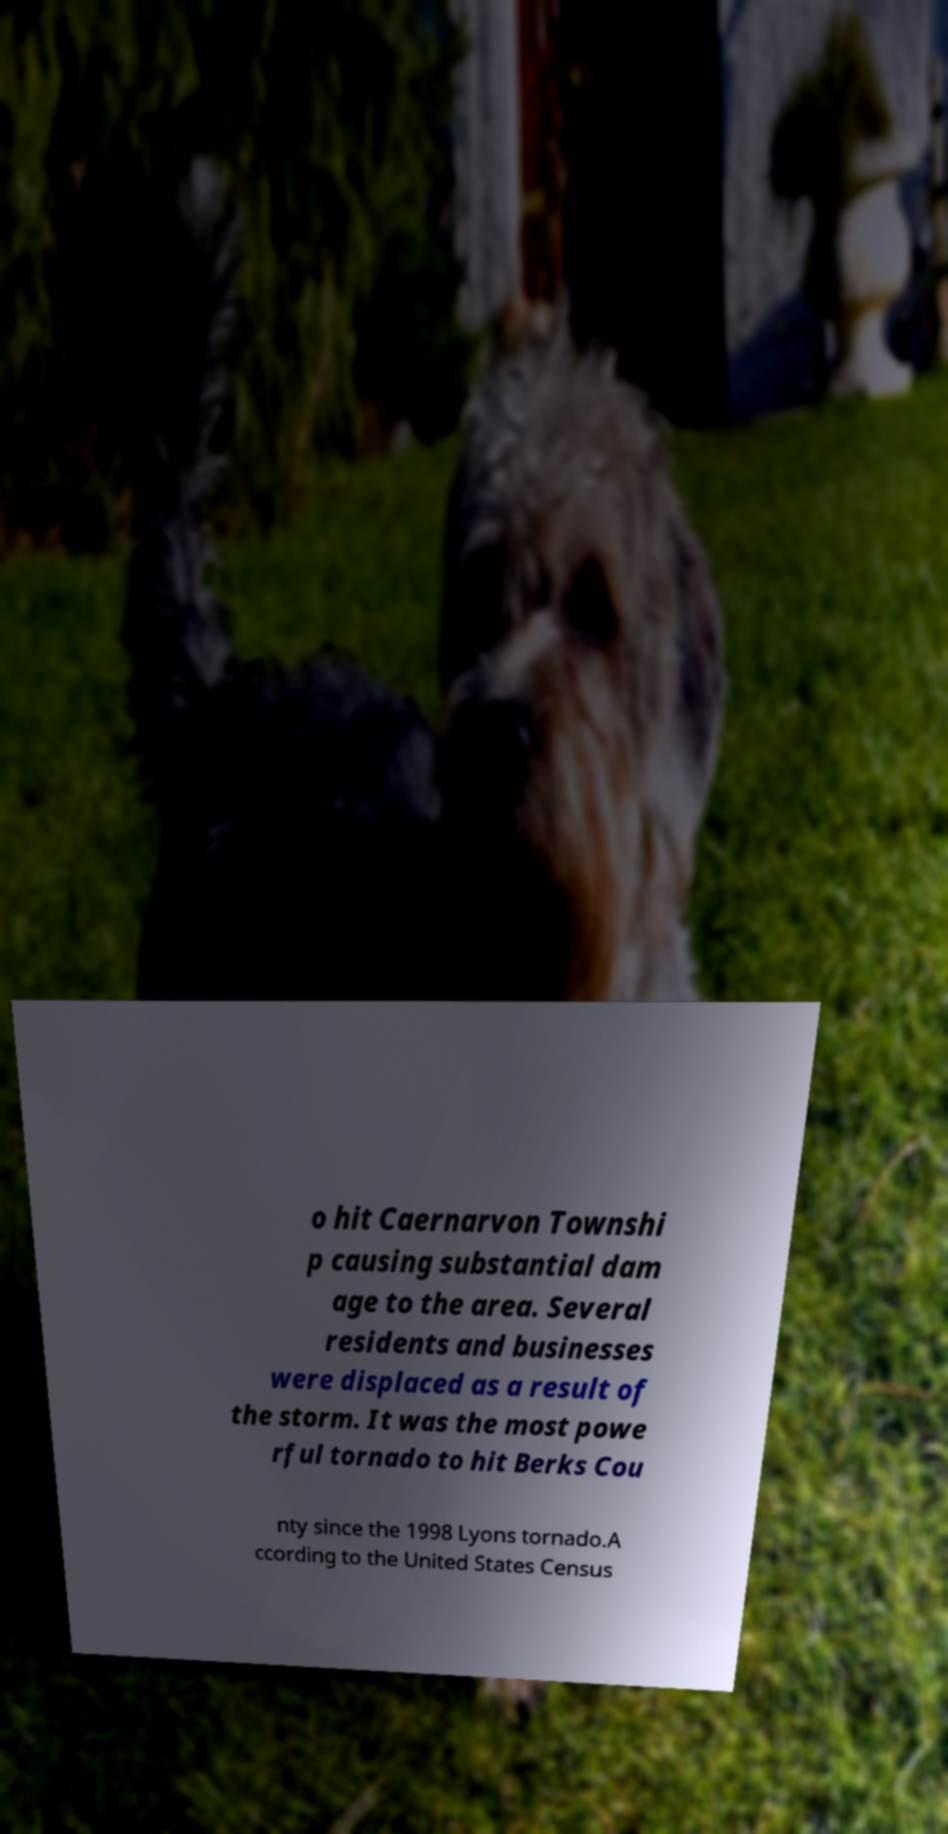I need the written content from this picture converted into text. Can you do that? o hit Caernarvon Townshi p causing substantial dam age to the area. Several residents and businesses were displaced as a result of the storm. It was the most powe rful tornado to hit Berks Cou nty since the 1998 Lyons tornado.A ccording to the United States Census 